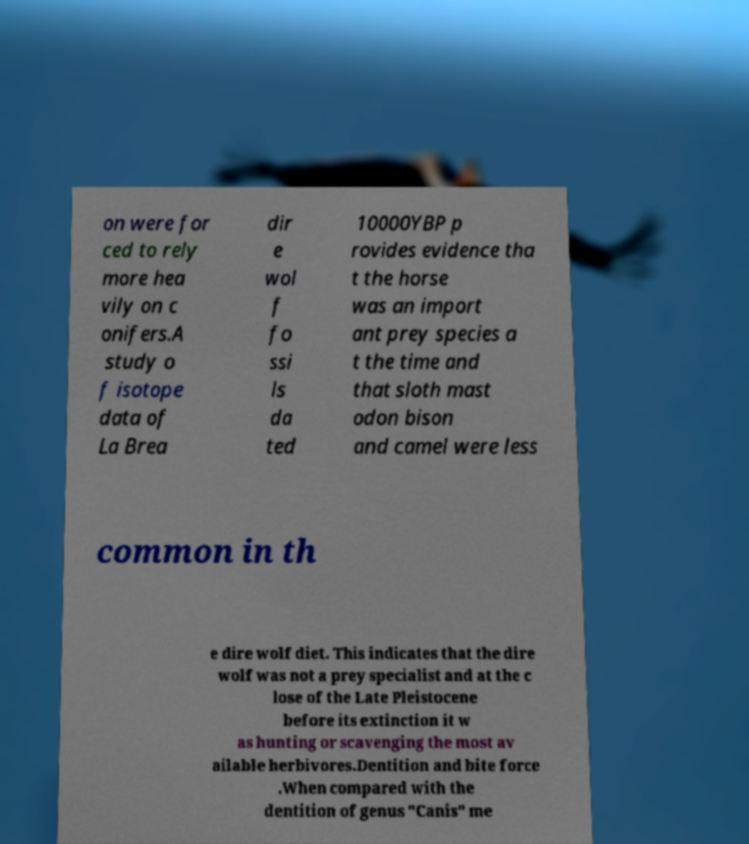Could you extract and type out the text from this image? on were for ced to rely more hea vily on c onifers.A study o f isotope data of La Brea dir e wol f fo ssi ls da ted 10000YBP p rovides evidence tha t the horse was an import ant prey species a t the time and that sloth mast odon bison and camel were less common in th e dire wolf diet. This indicates that the dire wolf was not a prey specialist and at the c lose of the Late Pleistocene before its extinction it w as hunting or scavenging the most av ailable herbivores.Dentition and bite force .When compared with the dentition of genus "Canis" me 